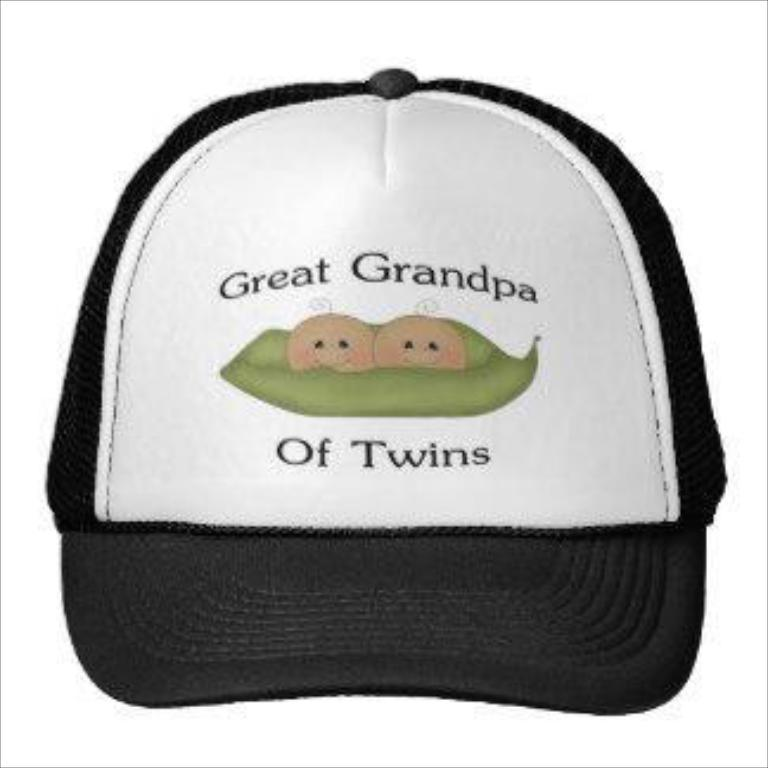What object is featured in the image? There is a cap in the image. What colors can be seen on the cap? The cap is white and black in color. Are there any words or symbols on the cap? Yes, there is writing on the cap. What color is the background of the image? The background of the image is white. How many cents are visible on the cap in the image? There are no cents visible on the cap in the image. What type of brush is being used to paint the cap in the image? There is no brush or painting activity depicted in the image; it only shows a cap with writing on it. 